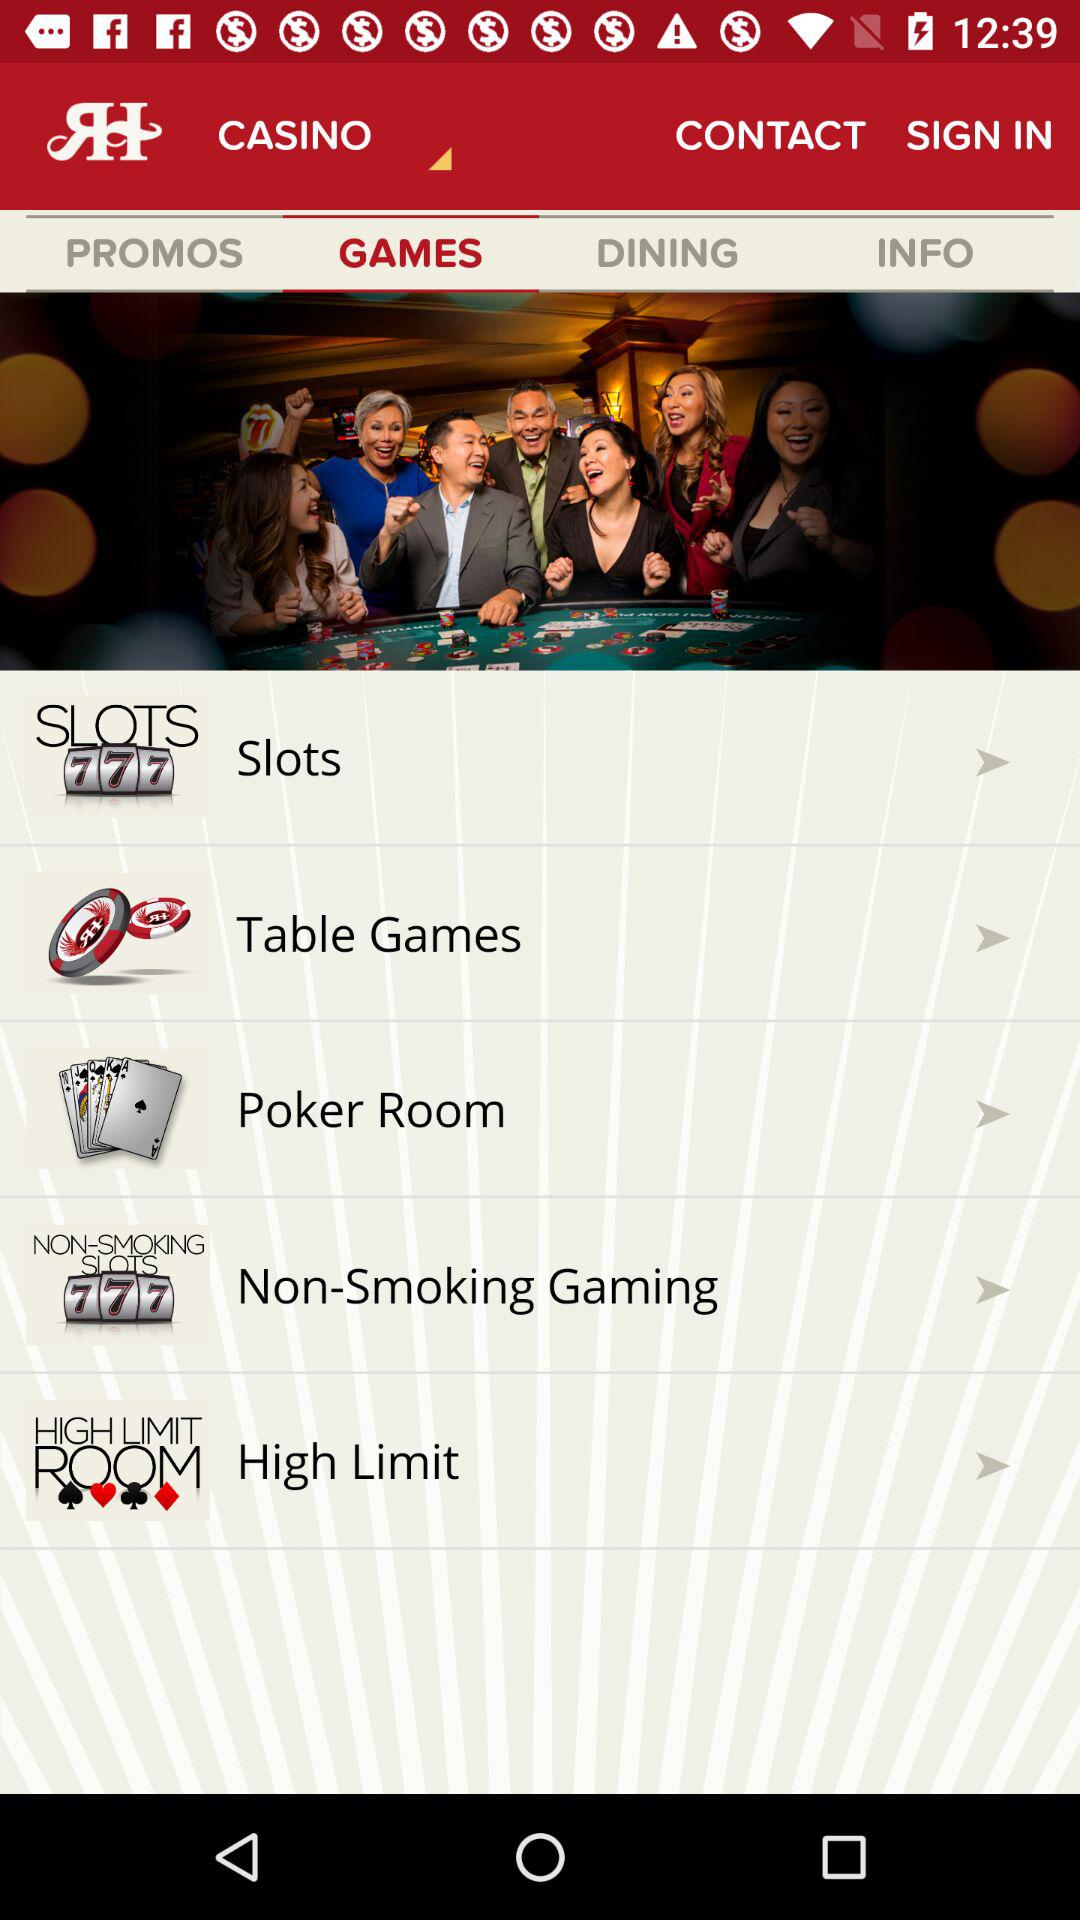What are the available games? The available games are "Slots", "Table Games", "Poker Room", "Non-Smoking Gaming" and "High Limit". 